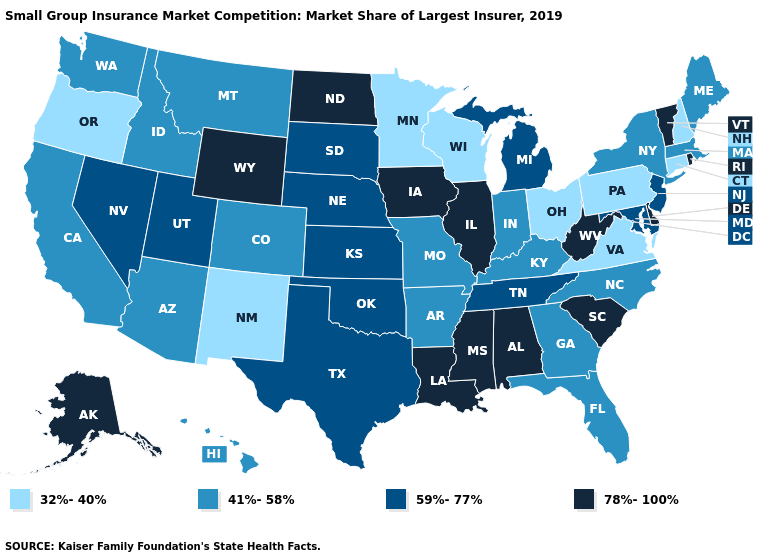Does the first symbol in the legend represent the smallest category?
Keep it brief. Yes. Which states hav the highest value in the Northeast?
Be succinct. Rhode Island, Vermont. Among the states that border Montana , which have the lowest value?
Quick response, please. Idaho. Among the states that border Arkansas , which have the lowest value?
Concise answer only. Missouri. Which states have the lowest value in the South?
Quick response, please. Virginia. Does Texas have the lowest value in the South?
Write a very short answer. No. Does Alabama have the highest value in the South?
Write a very short answer. Yes. Does Kentucky have the highest value in the USA?
Write a very short answer. No. What is the lowest value in states that border Nevada?
Give a very brief answer. 32%-40%. How many symbols are there in the legend?
Write a very short answer. 4. What is the highest value in states that border Delaware?
Short answer required. 59%-77%. Does Georgia have a lower value than Mississippi?
Keep it brief. Yes. Which states have the lowest value in the USA?
Give a very brief answer. Connecticut, Minnesota, New Hampshire, New Mexico, Ohio, Oregon, Pennsylvania, Virginia, Wisconsin. Does Illinois have a higher value than Iowa?
Write a very short answer. No. What is the value of Oklahoma?
Concise answer only. 59%-77%. 